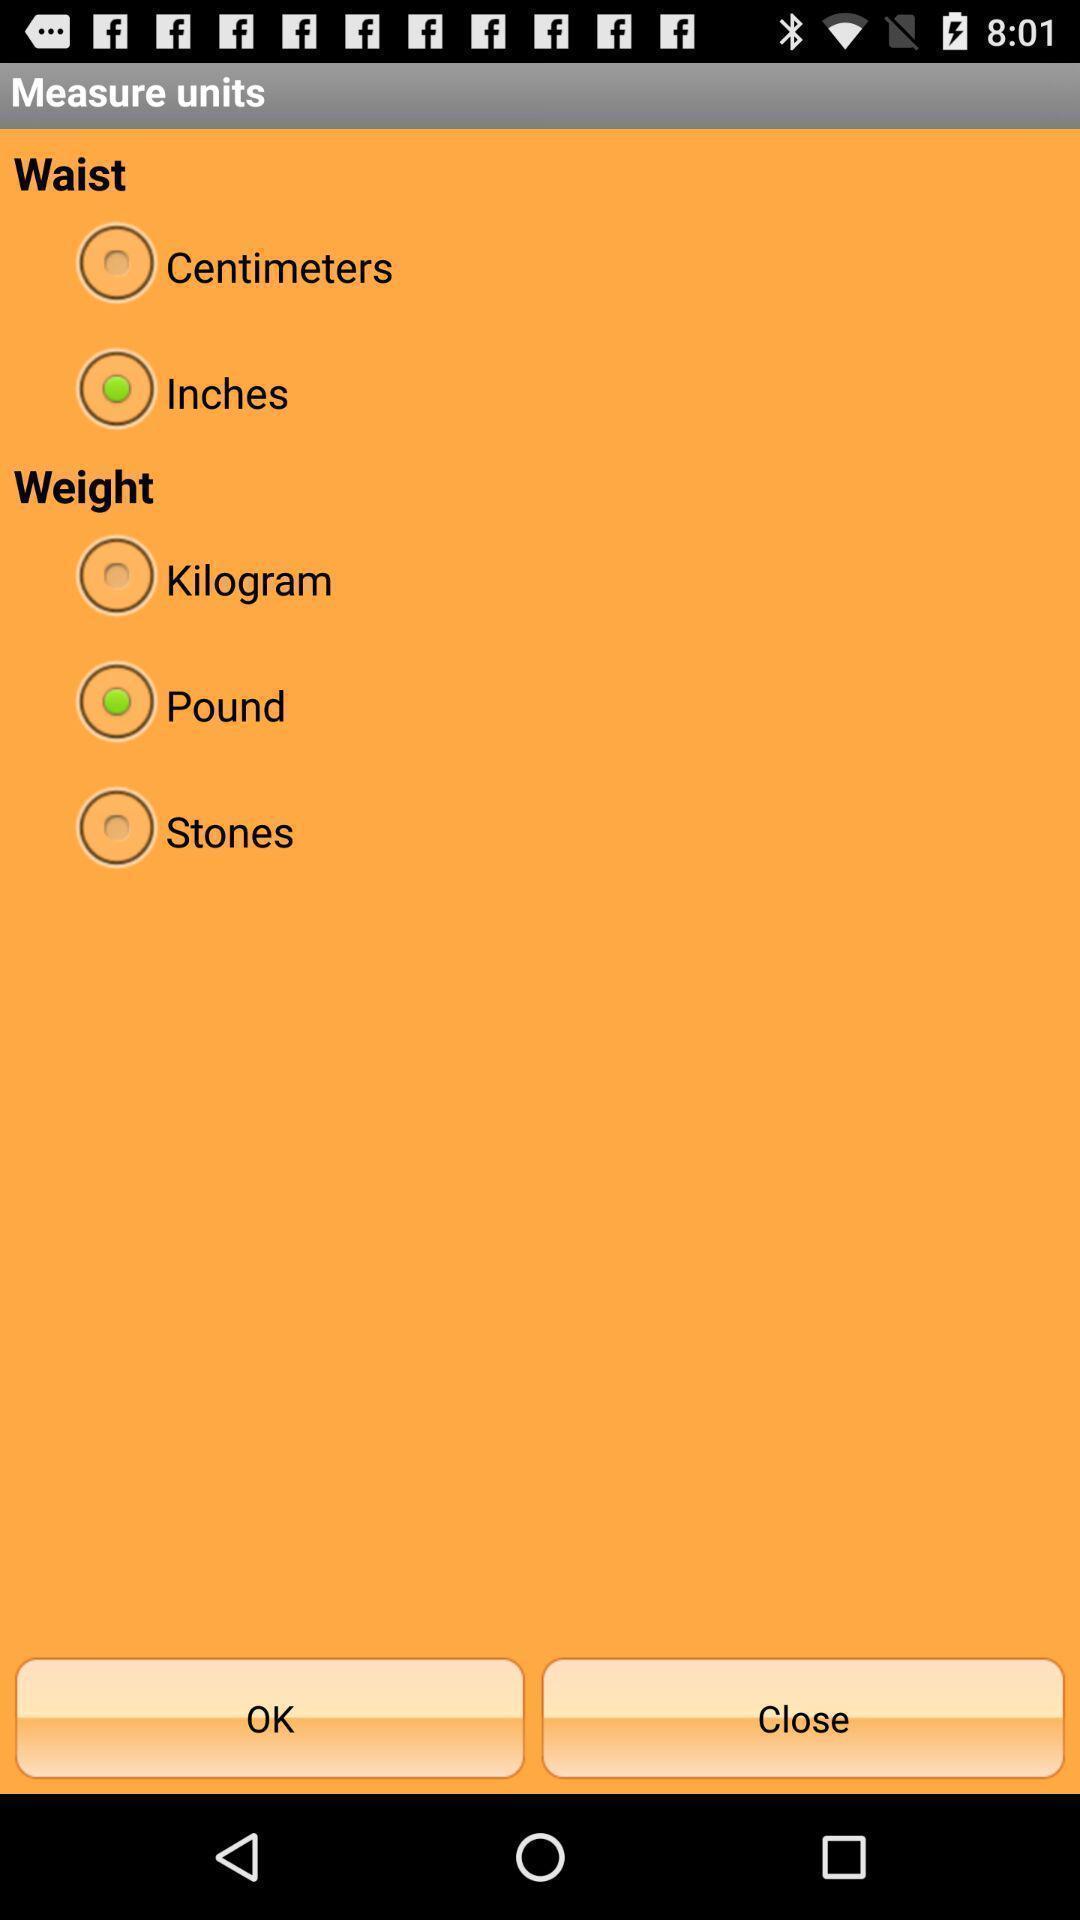Summarize the information in this screenshot. Page showing the options for measurement units. 